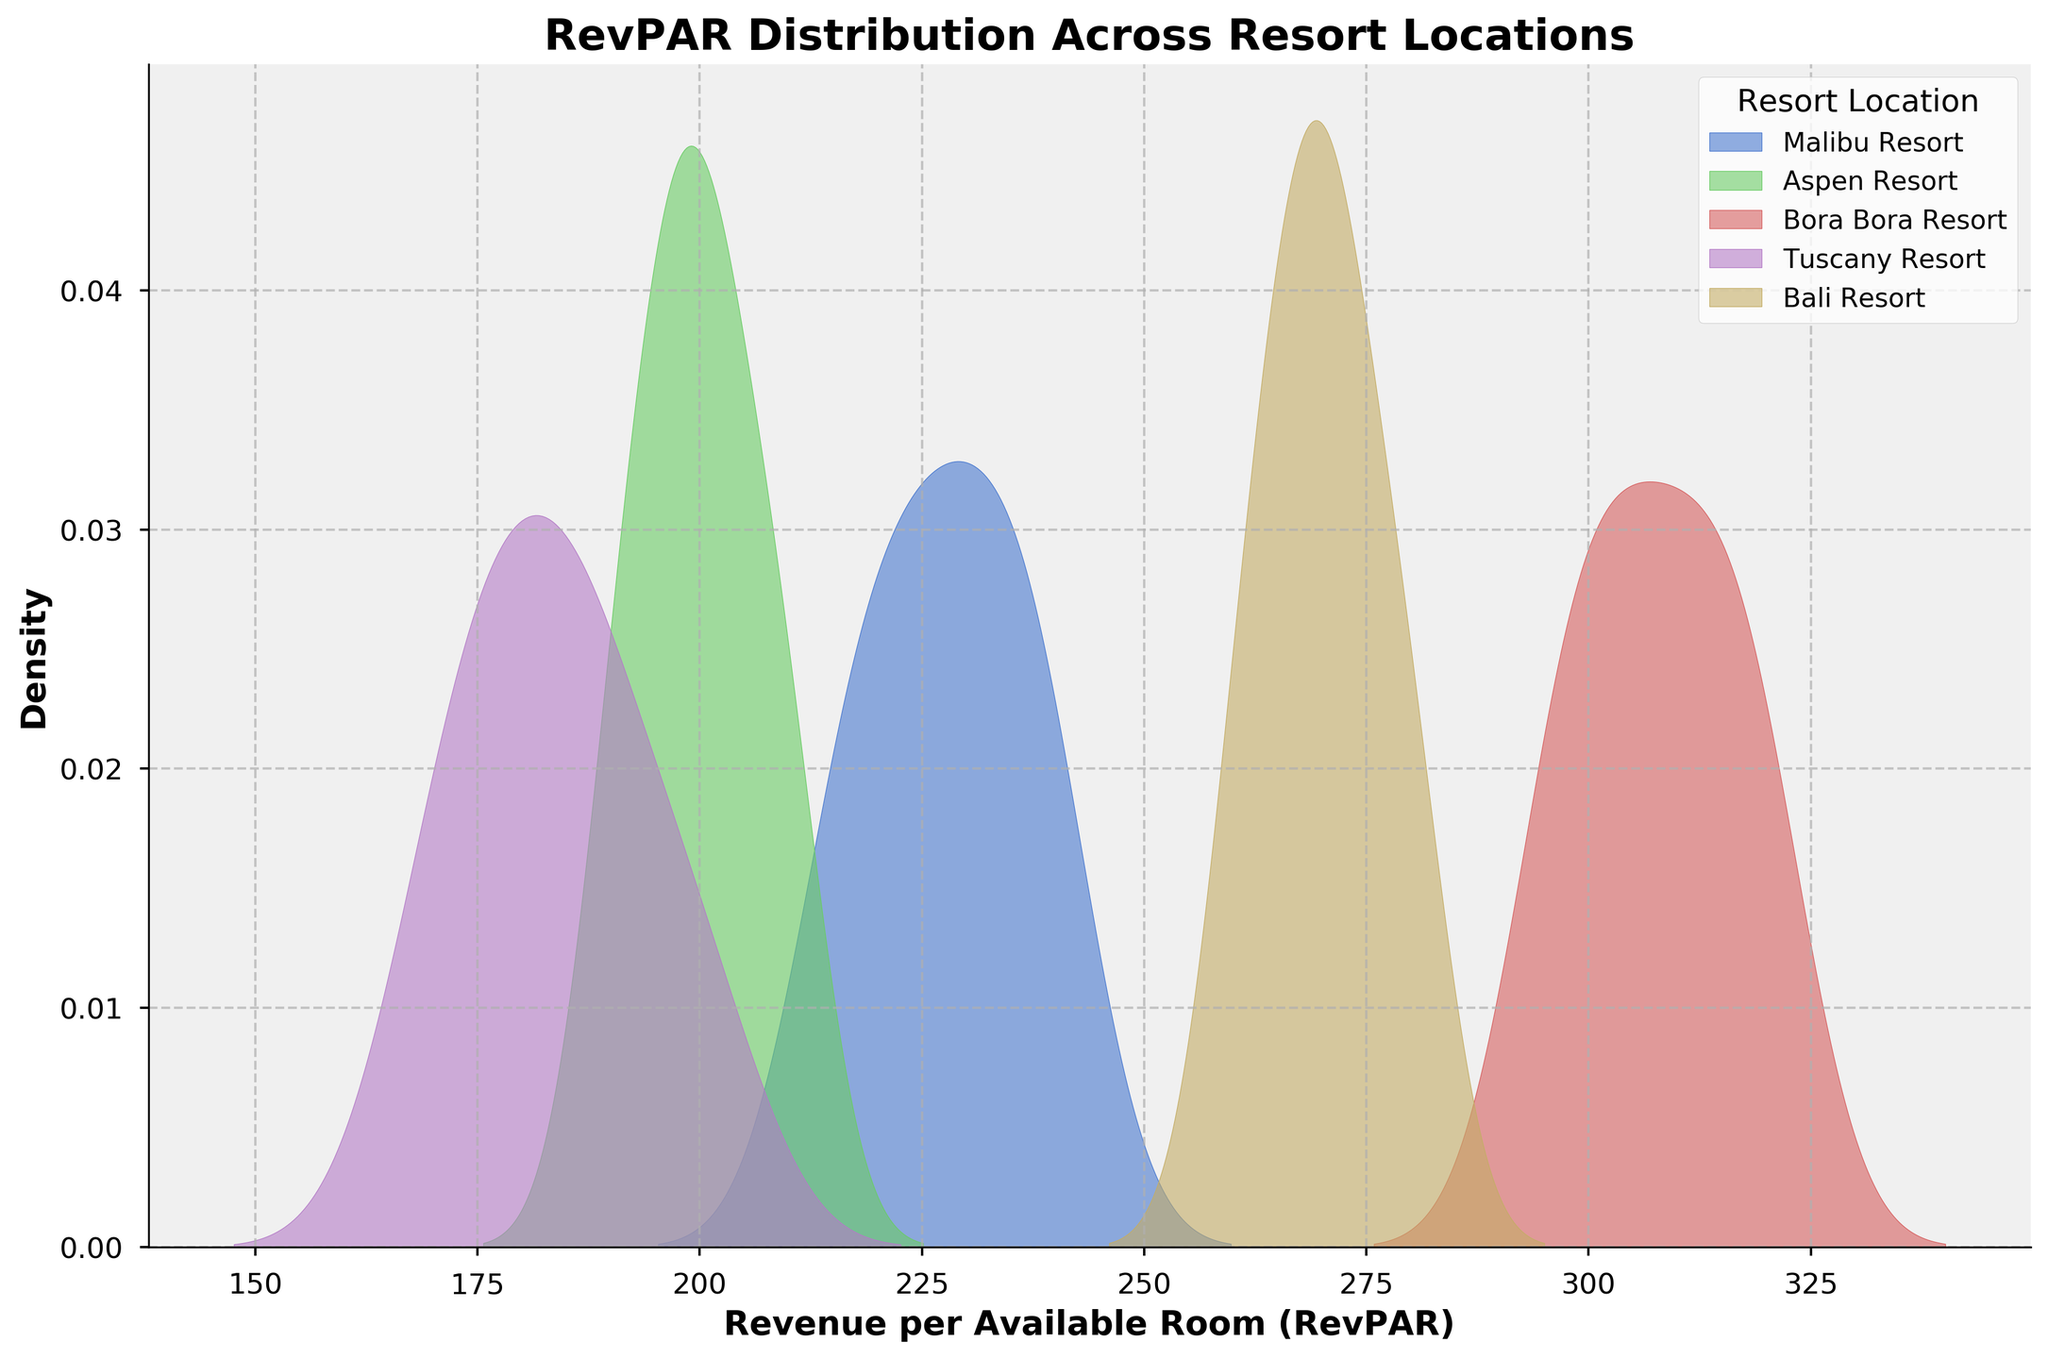What is the title of the plot? The title of the plot is typically located at the top center of the figure and provides a brief description of the plot's content. Here, it reads "RevPAR Distribution Across Resort Locations."
Answer: RevPAR Distribution Across Resort Locations Which resort location has the highest peak density in RevPAR? Looking at the density curves, the peak density (highest point of the curve) indicates the value around which most data points are concentrated. The resort with the highest peak density appears to be Bora Bora Resort.
Answer: Bora Bora Resort What is the approximate range of RevPAR for Aspen Resort? The range can be estimated by observing the density curve's spread on the x-axis. For Aspen Resort, it appears to lie roughly between 190 and 210.
Answer: 190 to 210 Which two resort locations have overlapping RevPAR distributions? Overlapping distributions can be identified by examining where the density curves of different resorts intersect. The density curves for Bali Resort and Malibu Resort appear to overlap significantly.
Answer: Bali Resort and Malibu Resort How does the peak density of Tuscany Resort compare to that of Bali Resort? A comparison of the peak densities can be made by observing the highest points on their respective density curves. Tuscany Resort has a lower peak density compared to Bali Resort.
Answer: Lower Which resort has the broadest RevPAR distribution? The broadest distribution is indicated by the density curve that spreads the most along the x-axis. Aspen Resort's curve is spread out much more than the others, indicating a broad RevPAR distribution.
Answer: Aspen Resort Is there any resort location with a distinctly higher RevPAR compared to others? A distinctly higher RevPAR would be indicated by a density curve that is shifted to the right, towards higher values, without overlap from others. Bora Bora Resort’s density curve is distinctly positioned at higher RevPAR values, distinguishing it from the other resorts.
Answer: Bora Bora Resort Compare the peak RevPAR values of Malibu Resort and Bali Resort. By inspecting the highest points (peaks) of the density curves, we can see that Malibu Resort's peak RevPAR values are slightly higher than those of Bali Resort.
Answer: Malibu Resort's peak is higher than Bali Resort's Which resort location has the lowest peak density? The lowest peak density is determined by observing the density curve with the smallest peak. Tuscany Resort has the lowest peak density among all the resort locations.
Answer: Tuscany Resort 